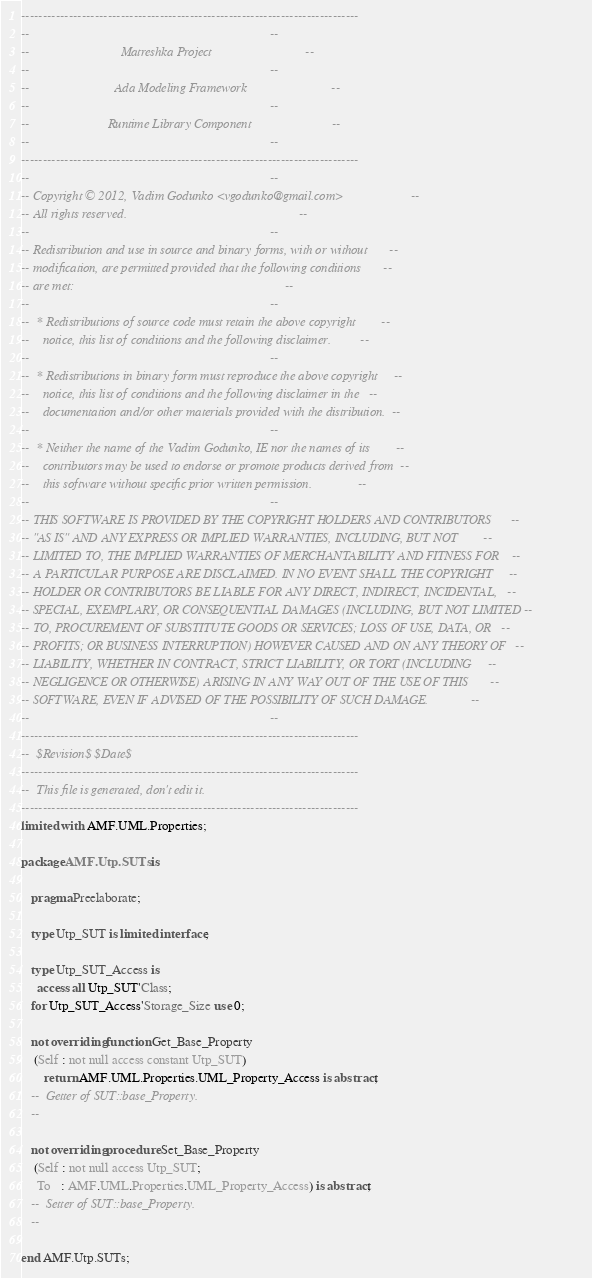Convert code to text. <code><loc_0><loc_0><loc_500><loc_500><_Ada_>------------------------------------------------------------------------------
--                                                                          --
--                            Matreshka Project                             --
--                                                                          --
--                          Ada Modeling Framework                          --
--                                                                          --
--                        Runtime Library Component                         --
--                                                                          --
------------------------------------------------------------------------------
--                                                                          --
-- Copyright © 2012, Vadim Godunko <vgodunko@gmail.com>                     --
-- All rights reserved.                                                     --
--                                                                          --
-- Redistribution and use in source and binary forms, with or without       --
-- modification, are permitted provided that the following conditions       --
-- are met:                                                                 --
--                                                                          --
--  * Redistributions of source code must retain the above copyright        --
--    notice, this list of conditions and the following disclaimer.         --
--                                                                          --
--  * Redistributions in binary form must reproduce the above copyright     --
--    notice, this list of conditions and the following disclaimer in the   --
--    documentation and/or other materials provided with the distribution.  --
--                                                                          --
--  * Neither the name of the Vadim Godunko, IE nor the names of its        --
--    contributors may be used to endorse or promote products derived from  --
--    this software without specific prior written permission.              --
--                                                                          --
-- THIS SOFTWARE IS PROVIDED BY THE COPYRIGHT HOLDERS AND CONTRIBUTORS      --
-- "AS IS" AND ANY EXPRESS OR IMPLIED WARRANTIES, INCLUDING, BUT NOT        --
-- LIMITED TO, THE IMPLIED WARRANTIES OF MERCHANTABILITY AND FITNESS FOR    --
-- A PARTICULAR PURPOSE ARE DISCLAIMED. IN NO EVENT SHALL THE COPYRIGHT     --
-- HOLDER OR CONTRIBUTORS BE LIABLE FOR ANY DIRECT, INDIRECT, INCIDENTAL,   --
-- SPECIAL, EXEMPLARY, OR CONSEQUENTIAL DAMAGES (INCLUDING, BUT NOT LIMITED --
-- TO, PROCUREMENT OF SUBSTITUTE GOODS OR SERVICES; LOSS OF USE, DATA, OR   --
-- PROFITS; OR BUSINESS INTERRUPTION) HOWEVER CAUSED AND ON ANY THEORY OF   --
-- LIABILITY, WHETHER IN CONTRACT, STRICT LIABILITY, OR TORT (INCLUDING     --
-- NEGLIGENCE OR OTHERWISE) ARISING IN ANY WAY OUT OF THE USE OF THIS       --
-- SOFTWARE, EVEN IF ADVISED OF THE POSSIBILITY OF SUCH DAMAGE.             --
--                                                                          --
------------------------------------------------------------------------------
--  $Revision$ $Date$
------------------------------------------------------------------------------
--  This file is generated, don't edit it.
------------------------------------------------------------------------------
limited with AMF.UML.Properties;

package AMF.Utp.SUTs is

   pragma Preelaborate;

   type Utp_SUT is limited interface;

   type Utp_SUT_Access is
     access all Utp_SUT'Class;
   for Utp_SUT_Access'Storage_Size use 0;

   not overriding function Get_Base_Property
    (Self : not null access constant Utp_SUT)
       return AMF.UML.Properties.UML_Property_Access is abstract;
   --  Getter of SUT::base_Property.
   --

   not overriding procedure Set_Base_Property
    (Self : not null access Utp_SUT;
     To   : AMF.UML.Properties.UML_Property_Access) is abstract;
   --  Setter of SUT::base_Property.
   --

end AMF.Utp.SUTs;
</code> 